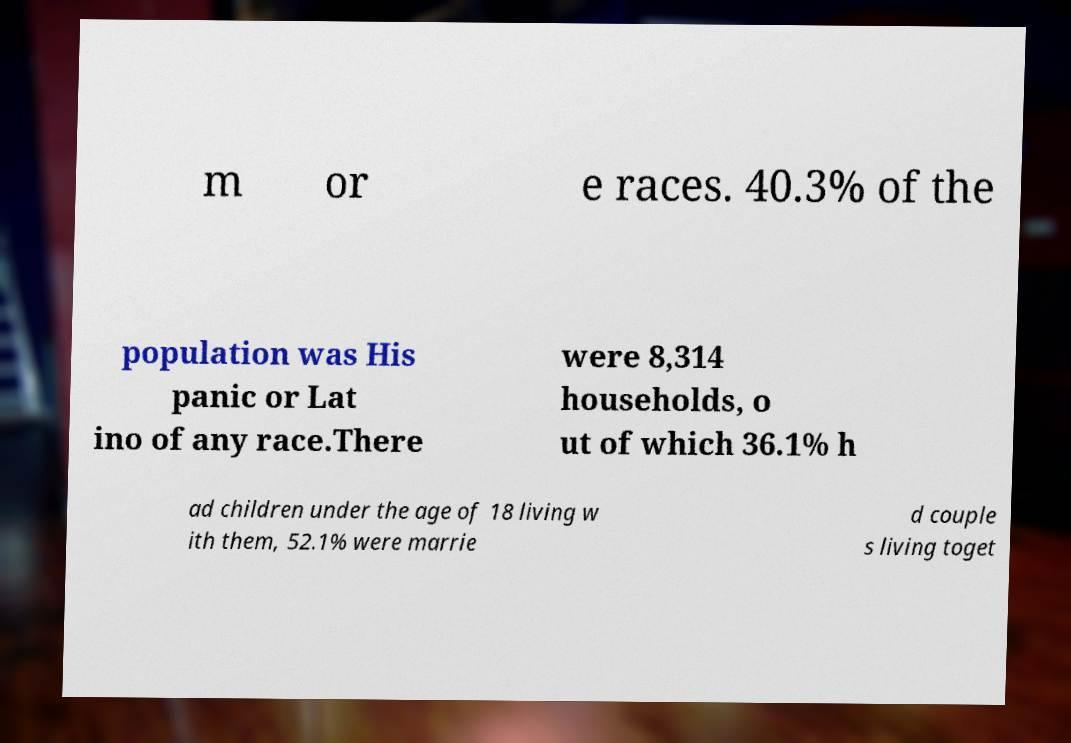There's text embedded in this image that I need extracted. Can you transcribe it verbatim? m or e races. 40.3% of the population was His panic or Lat ino of any race.There were 8,314 households, o ut of which 36.1% h ad children under the age of 18 living w ith them, 52.1% were marrie d couple s living toget 